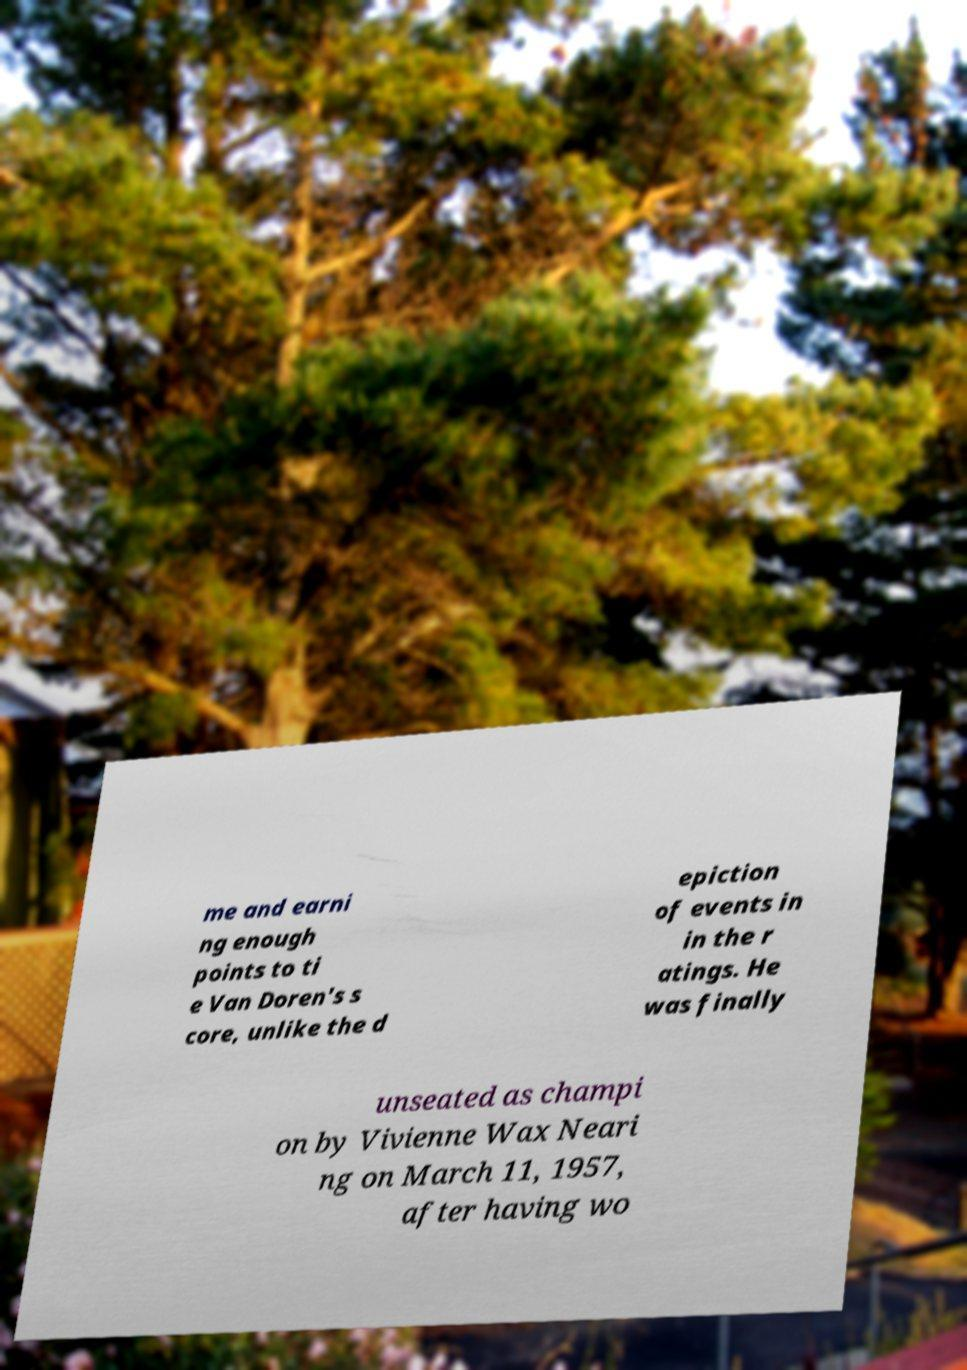Could you assist in decoding the text presented in this image and type it out clearly? me and earni ng enough points to ti e Van Doren's s core, unlike the d epiction of events in in the r atings. He was finally unseated as champi on by Vivienne Wax Neari ng on March 11, 1957, after having wo 